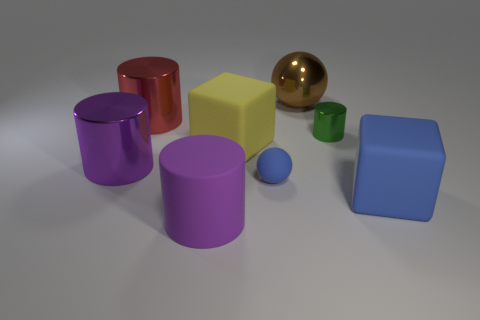How many things are large shiny things or small green metal objects?
Give a very brief answer. 4. How many other things are there of the same color as the large matte cylinder?
Your answer should be very brief. 1. What shape is the green shiny object that is the same size as the blue matte ball?
Your answer should be very brief. Cylinder. The big shiny cylinder in front of the green cylinder is what color?
Give a very brief answer. Purple. What number of objects are cylinders behind the small green metallic object or large blocks behind the small blue thing?
Ensure brevity in your answer.  2. Does the brown shiny object have the same size as the green cylinder?
Your answer should be compact. No. How many cubes are either blue objects or big gray metal objects?
Offer a terse response. 1. How many objects are to the left of the blue matte cube and in front of the red metallic object?
Give a very brief answer. 5. Do the yellow matte thing and the purple thing that is behind the small blue matte sphere have the same size?
Make the answer very short. Yes. There is a metallic object behind the metal cylinder that is behind the green thing; are there any metallic things left of it?
Keep it short and to the point. Yes. 